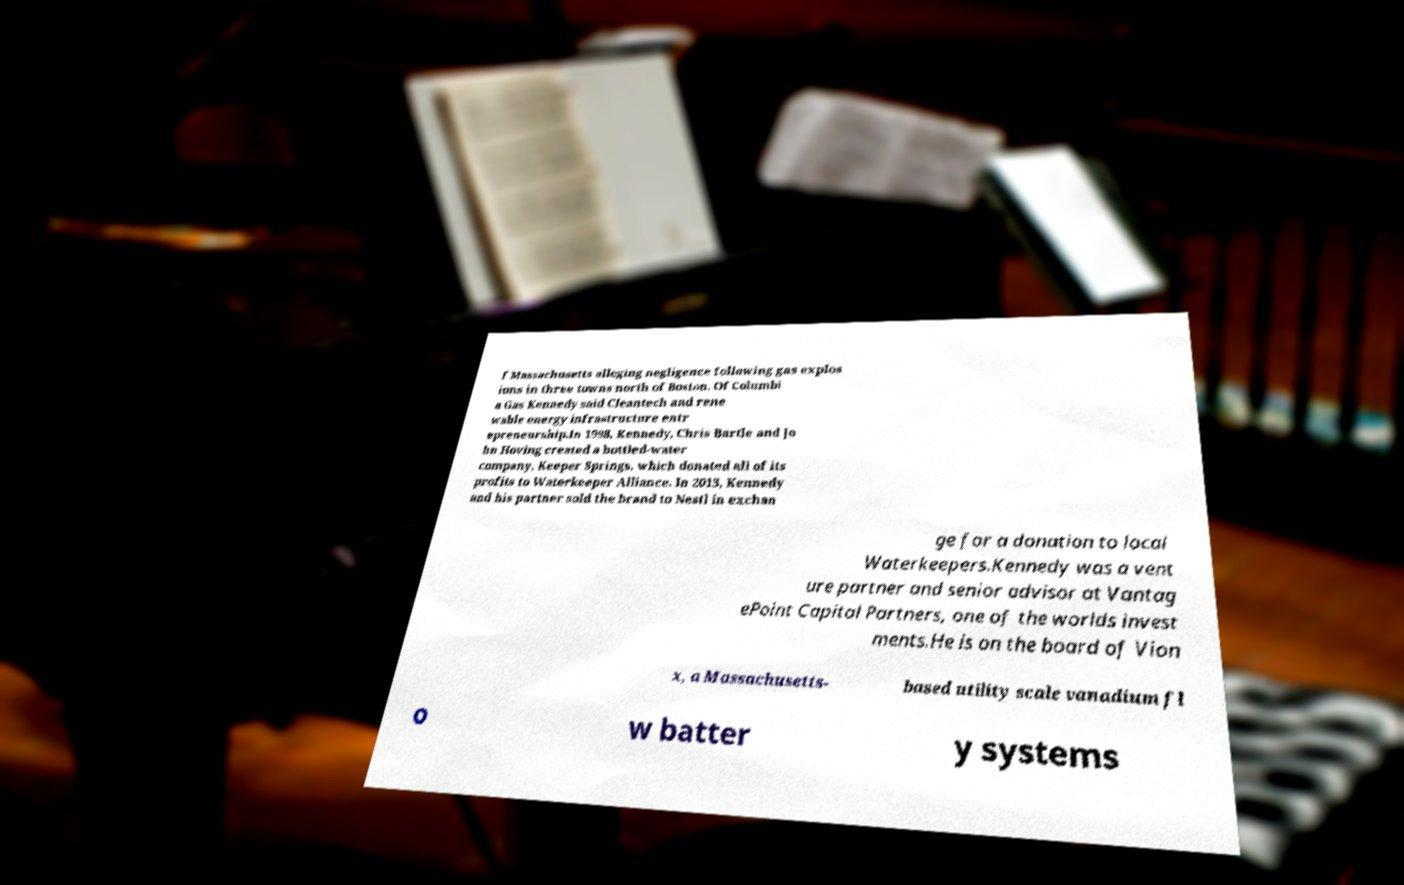For documentation purposes, I need the text within this image transcribed. Could you provide that? f Massachusetts alleging negligence following gas explos ions in three towns north of Boston. Of Columbi a Gas Kennedy said Cleantech and rene wable energy infrastructure entr epreneurship.In 1998, Kennedy, Chris Bartle and Jo hn Hoving created a bottled-water company, Keeper Springs, which donated all of its profits to Waterkeeper Alliance. In 2013, Kennedy and his partner sold the brand to Nestl in exchan ge for a donation to local Waterkeepers.Kennedy was a vent ure partner and senior advisor at Vantag ePoint Capital Partners, one of the worlds invest ments.He is on the board of Vion x, a Massachusetts- based utility scale vanadium fl o w batter y systems 